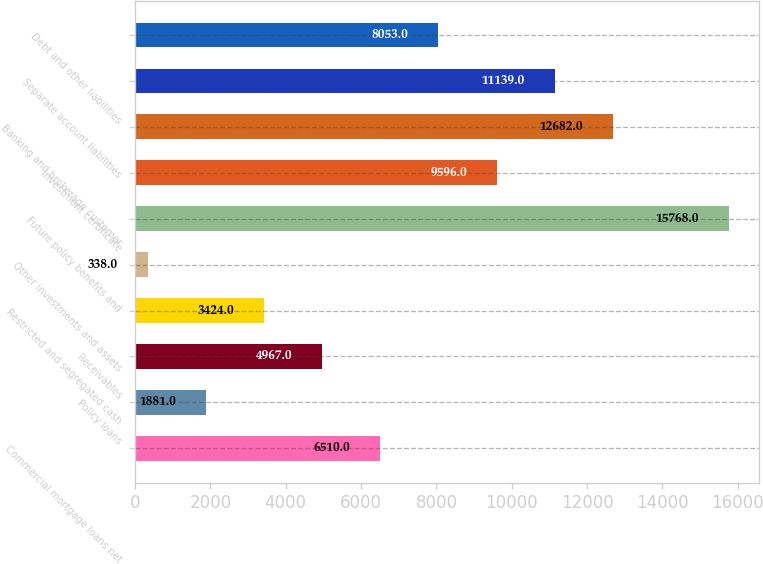Convert chart. <chart><loc_0><loc_0><loc_500><loc_500><bar_chart><fcel>Commercial mortgage loans net<fcel>Policy loans<fcel>Receivables<fcel>Restricted and segregated cash<fcel>Other investments and assets<fcel>Future policy benefits and<fcel>Investment certificate<fcel>Banking and brokerage customer<fcel>Separate account liabilities<fcel>Debt and other liabilities<nl><fcel>6510<fcel>1881<fcel>4967<fcel>3424<fcel>338<fcel>15768<fcel>9596<fcel>12682<fcel>11139<fcel>8053<nl></chart> 